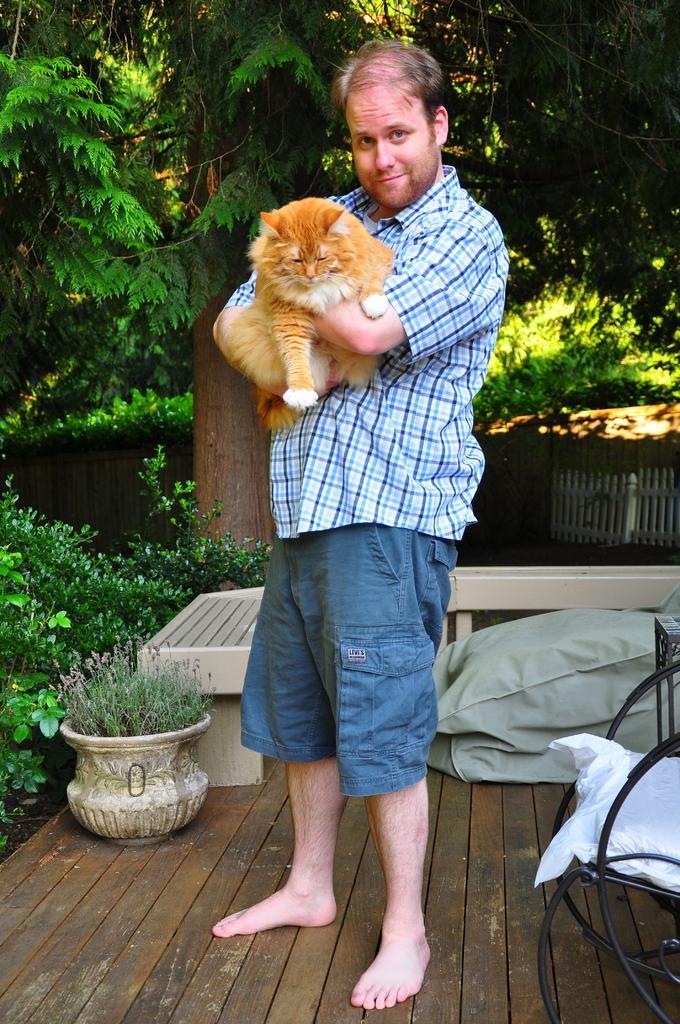How would you summarize this image in a sentence or two? in this picture the person is standing and catching a cat on his hand,here we can also see some trees and chair. 